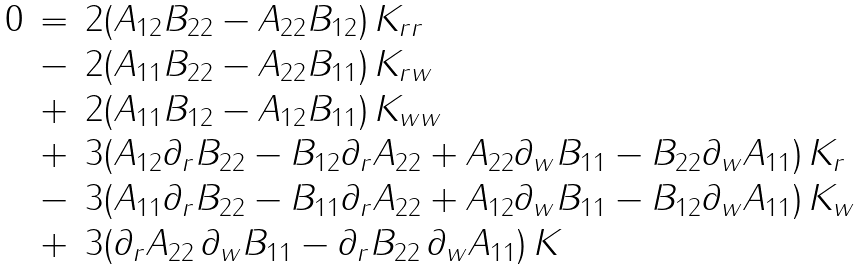Convert formula to latex. <formula><loc_0><loc_0><loc_500><loc_500>\begin{array} { r c l } 0 & = & 2 ( A _ { 1 2 } B _ { 2 2 } - A _ { 2 2 } B _ { 1 2 } ) \, K _ { r r } \\ & - & 2 ( A _ { 1 1 } B _ { 2 2 } - A _ { 2 2 } B _ { 1 1 } ) \, K _ { r w } \\ & + & 2 ( A _ { 1 1 } B _ { 1 2 } - A _ { 1 2 } B _ { 1 1 } ) \, K _ { w w } \\ & + & 3 ( A _ { 1 2 } \partial _ { r } B _ { 2 2 } - B _ { 1 2 } \partial _ { r } A _ { 2 2 } + A _ { 2 2 } \partial _ { w } B _ { 1 1 } - B _ { 2 2 } \partial _ { w } A _ { 1 1 } ) \, K _ { r } \\ & - & 3 ( A _ { 1 1 } \partial _ { r } B _ { 2 2 } - B _ { 1 1 } \partial _ { r } A _ { 2 2 } + A _ { 1 2 } \partial _ { w } B _ { 1 1 } - B _ { 1 2 } \partial _ { w } A _ { 1 1 } ) \, K _ { w } \\ & + & 3 ( \partial _ { r } A _ { 2 2 } \, \partial _ { w } B _ { 1 1 } - \partial _ { r } B _ { 2 2 } \, \partial _ { w } A _ { 1 1 } ) \, K \end{array}</formula> 